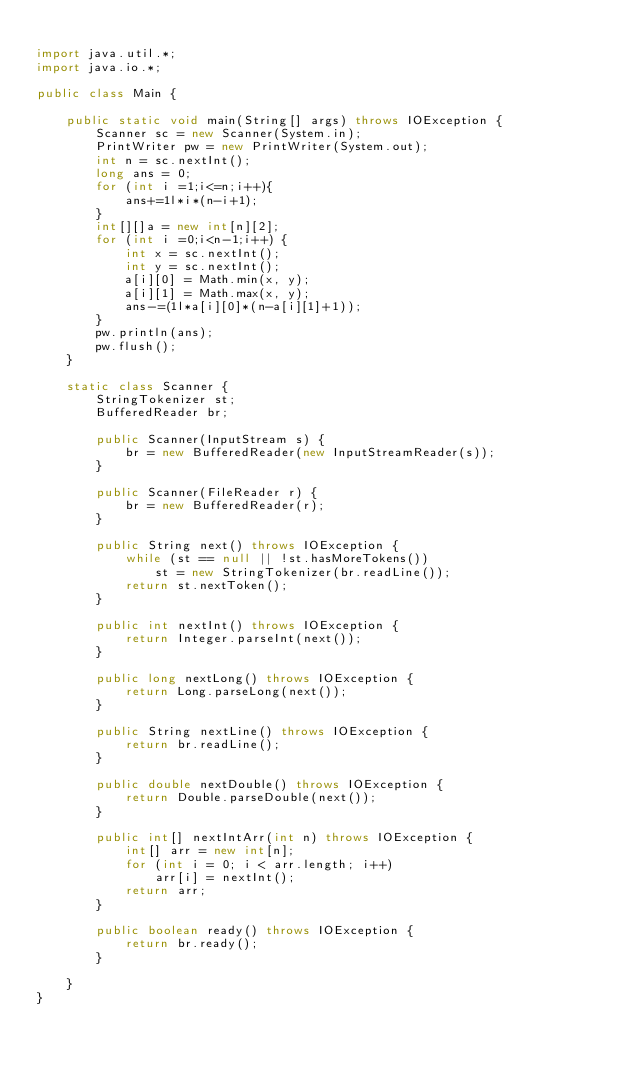Convert code to text. <code><loc_0><loc_0><loc_500><loc_500><_Java_>
import java.util.*;
import java.io.*;

public class Main {

    public static void main(String[] args) throws IOException {
        Scanner sc = new Scanner(System.in);
        PrintWriter pw = new PrintWriter(System.out);
        int n = sc.nextInt();
        long ans = 0;
        for (int i =1;i<=n;i++){
            ans+=1l*i*(n-i+1);
        }
        int[][]a = new int[n][2];
        for (int i =0;i<n-1;i++) {
            int x = sc.nextInt();
            int y = sc.nextInt();
            a[i][0] = Math.min(x, y);
            a[i][1] = Math.max(x, y);
            ans-=(1l*a[i][0]*(n-a[i][1]+1));
        }
        pw.println(ans);
        pw.flush();
    }

    static class Scanner {
        StringTokenizer st;
        BufferedReader br;

        public Scanner(InputStream s) {
            br = new BufferedReader(new InputStreamReader(s));
        }

        public Scanner(FileReader r) {
            br = new BufferedReader(r);
        }

        public String next() throws IOException {
            while (st == null || !st.hasMoreTokens())
                st = new StringTokenizer(br.readLine());
            return st.nextToken();
        }

        public int nextInt() throws IOException {
            return Integer.parseInt(next());
        }

        public long nextLong() throws IOException {
            return Long.parseLong(next());
        }

        public String nextLine() throws IOException {
            return br.readLine();
        }

        public double nextDouble() throws IOException {
            return Double.parseDouble(next());
        }

        public int[] nextIntArr(int n) throws IOException {
            int[] arr = new int[n];
            for (int i = 0; i < arr.length; i++)
                arr[i] = nextInt();
            return arr;
        }

        public boolean ready() throws IOException {
            return br.ready();
        }

    }
}</code> 